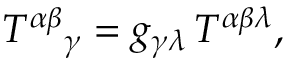Convert formula to latex. <formula><loc_0><loc_0><loc_500><loc_500>T ^ { \alpha \beta _ { \gamma } = g _ { \gamma \lambda } \, T ^ { \alpha \beta \lambda } ,</formula> 